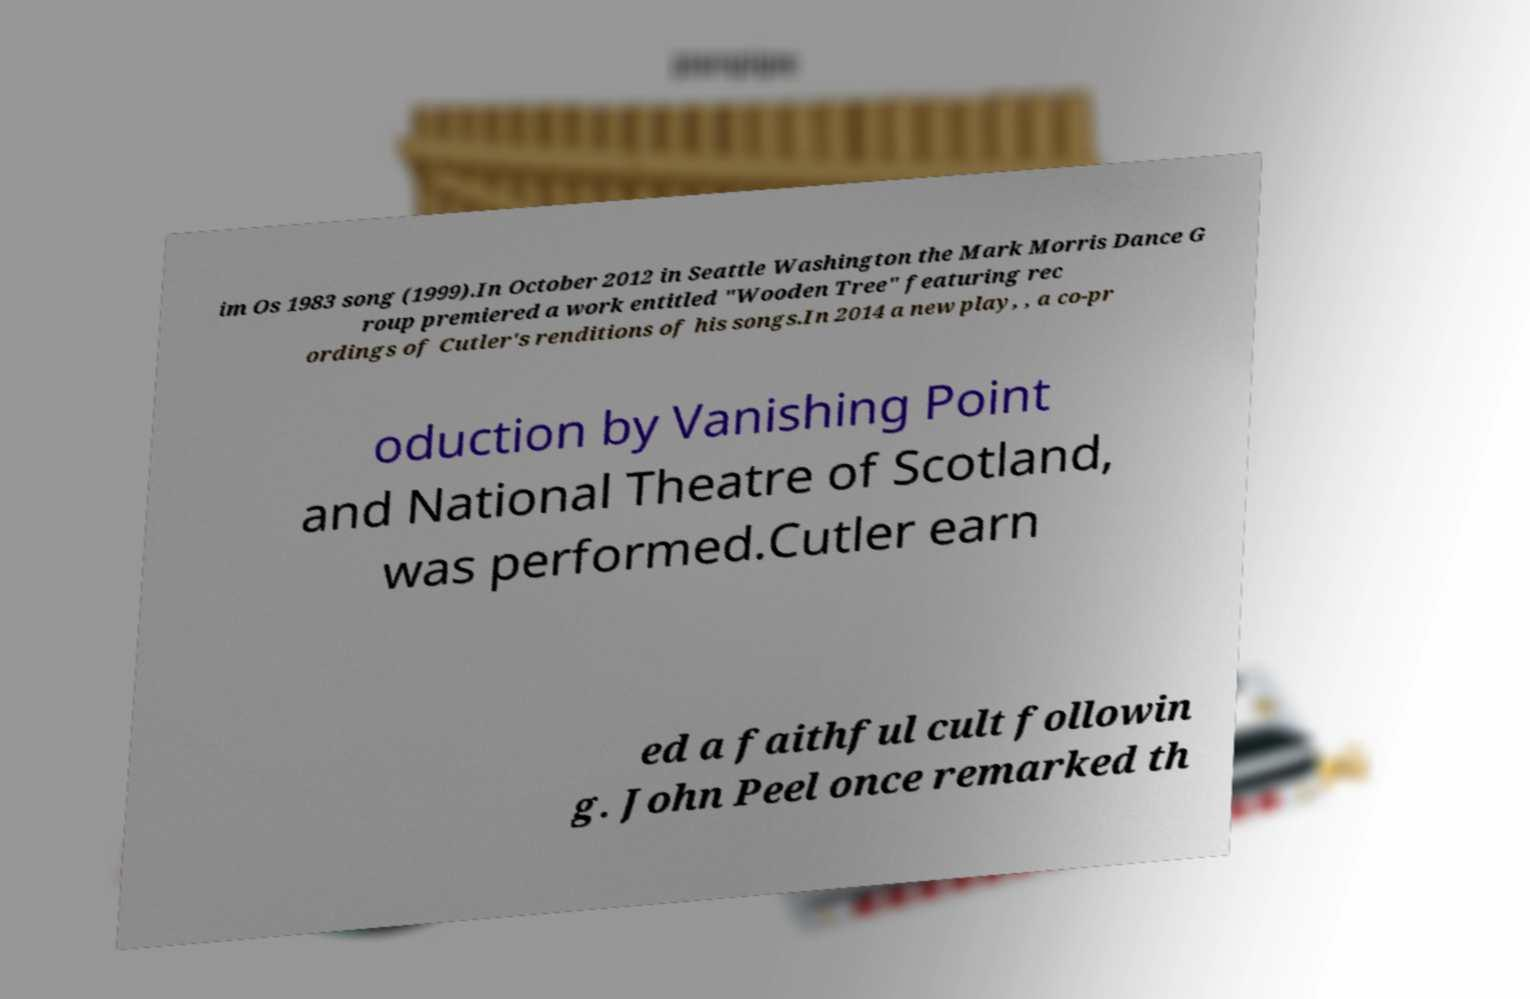Can you read and provide the text displayed in the image?This photo seems to have some interesting text. Can you extract and type it out for me? im Os 1983 song (1999).In October 2012 in Seattle Washington the Mark Morris Dance G roup premiered a work entitled "Wooden Tree" featuring rec ordings of Cutler's renditions of his songs.In 2014 a new play, , a co-pr oduction by Vanishing Point and National Theatre of Scotland, was performed.Cutler earn ed a faithful cult followin g. John Peel once remarked th 